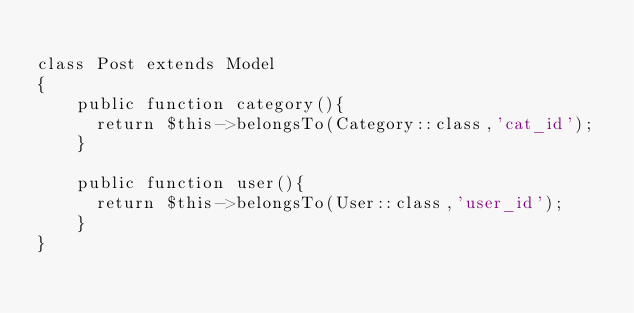Convert code to text. <code><loc_0><loc_0><loc_500><loc_500><_PHP_>
class Post extends Model
{
    public function category(){
    	return $this->belongsTo(Category::class,'cat_id');
    }

    public function user(){
    	return $this->belongsTo(User::class,'user_id');
    }
}
</code> 